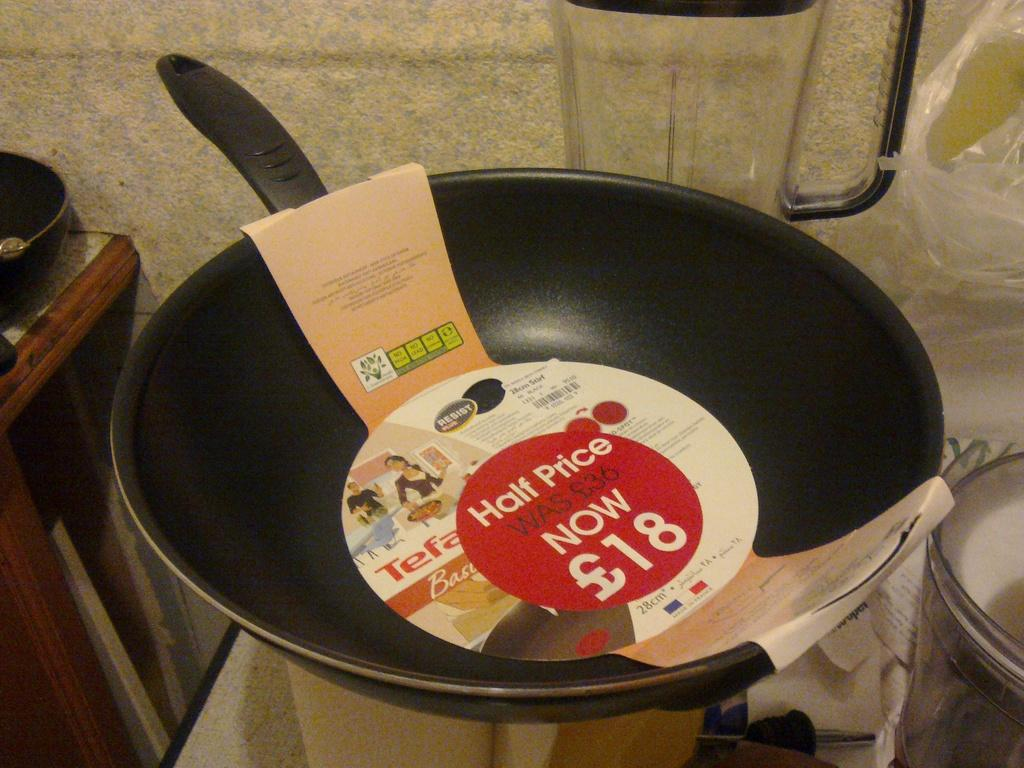<image>
Describe the image concisely. A frying pan that used to cost 36 pounds but now is half that. 